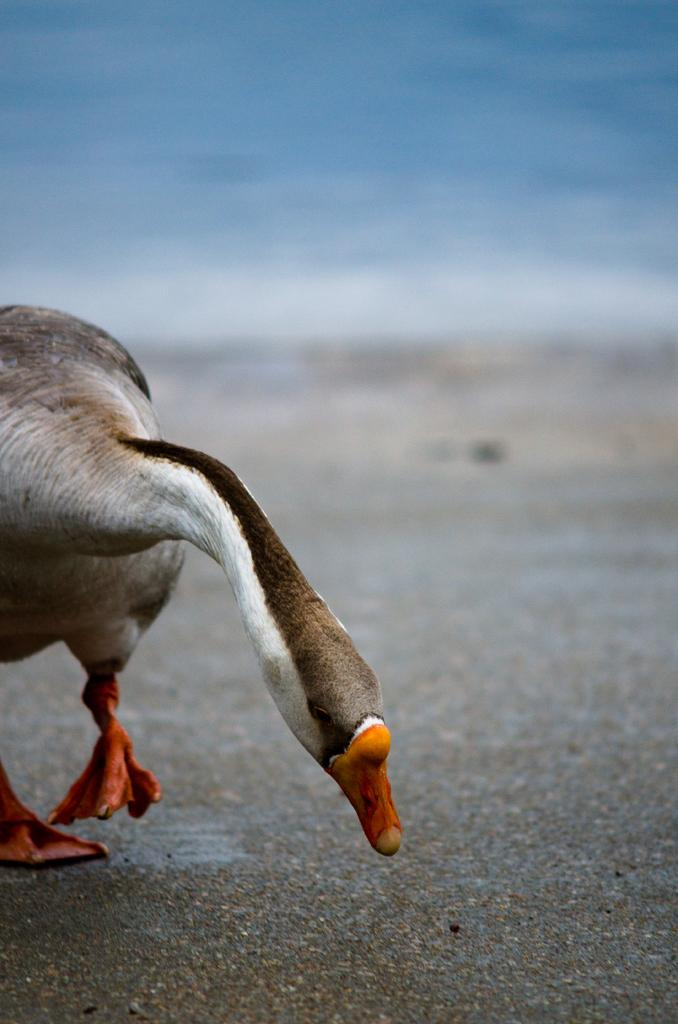What type of animal is in the image? There is a duck in the image. What colors can be seen on the duck? The duck has white and brown colors. Where is the duck located in the image? The duck is on the sand. What can be seen in the background of the image? There is water visible in the background of the image. What type of plants can be seen growing in the sleet in the image? There is no sleet or plants present in the image; it features a duck on the sand with water visible in the background. 